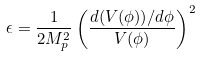<formula> <loc_0><loc_0><loc_500><loc_500>\epsilon = \frac { 1 } { 2 M _ { p } ^ { 2 } } \left ( \frac { d ( V ( \phi ) ) / d \phi } { V ( \phi ) } \right ) ^ { 2 }</formula> 